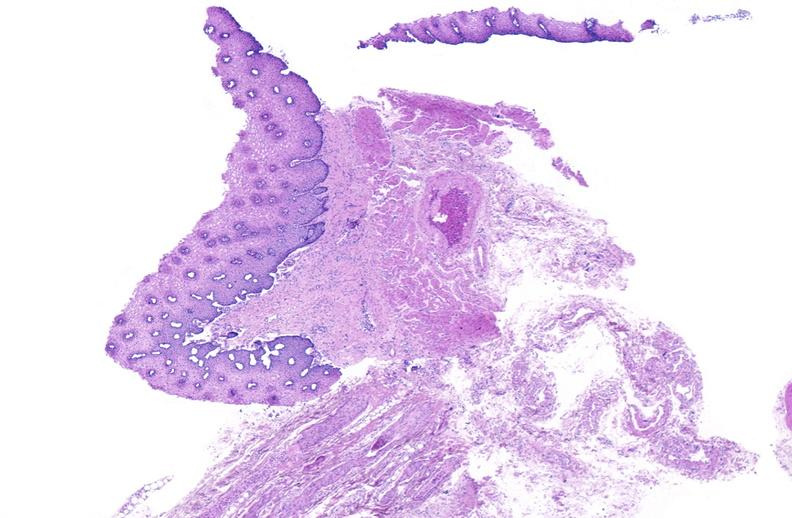where is this from?
Answer the question using a single word or phrase. Gastrointestinal system 